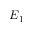<formula> <loc_0><loc_0><loc_500><loc_500>E _ { 1 }</formula> 